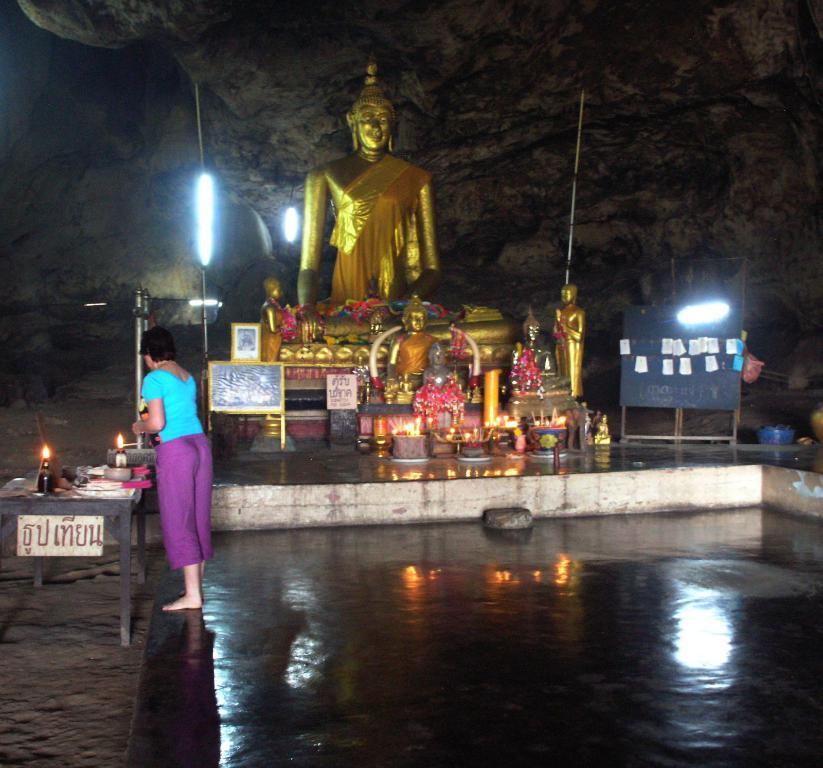How would you summarize this image in a sentence or two? In this image, on the left side, we can see a woman standing in front of the table. On the table, we can see some bottles with fire, cloth. In the background, we can see some statues, sculptures, board with some papers attached to it and a board with some paintings, lights. In the background, we can see some trees. At the bottom, we can see a land which is in black color. 